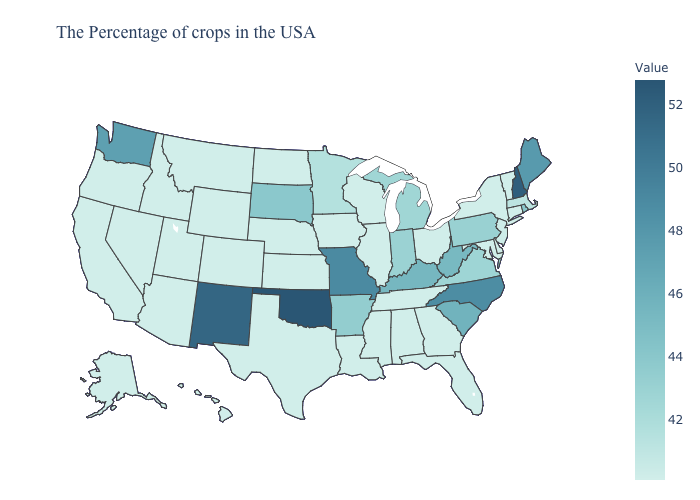Which states have the lowest value in the USA?
Write a very short answer. Vermont, Connecticut, New York, Delaware, Maryland, Ohio, Florida, Georgia, Alabama, Tennessee, Wisconsin, Illinois, Mississippi, Louisiana, Iowa, Kansas, Nebraska, Texas, North Dakota, Wyoming, Colorado, Utah, Montana, Arizona, Idaho, Nevada, California, Oregon, Alaska, Hawaii. Among the states that border North Dakota , which have the lowest value?
Keep it brief. Montana. Does Maine have the lowest value in the USA?
Keep it brief. No. Does Colorado have a higher value than Indiana?
Short answer required. No. Does Oklahoma have the highest value in the USA?
Answer briefly. Yes. Does Arkansas have the lowest value in the USA?
Concise answer only. No. Does Tennessee have a lower value than Missouri?
Be succinct. Yes. 